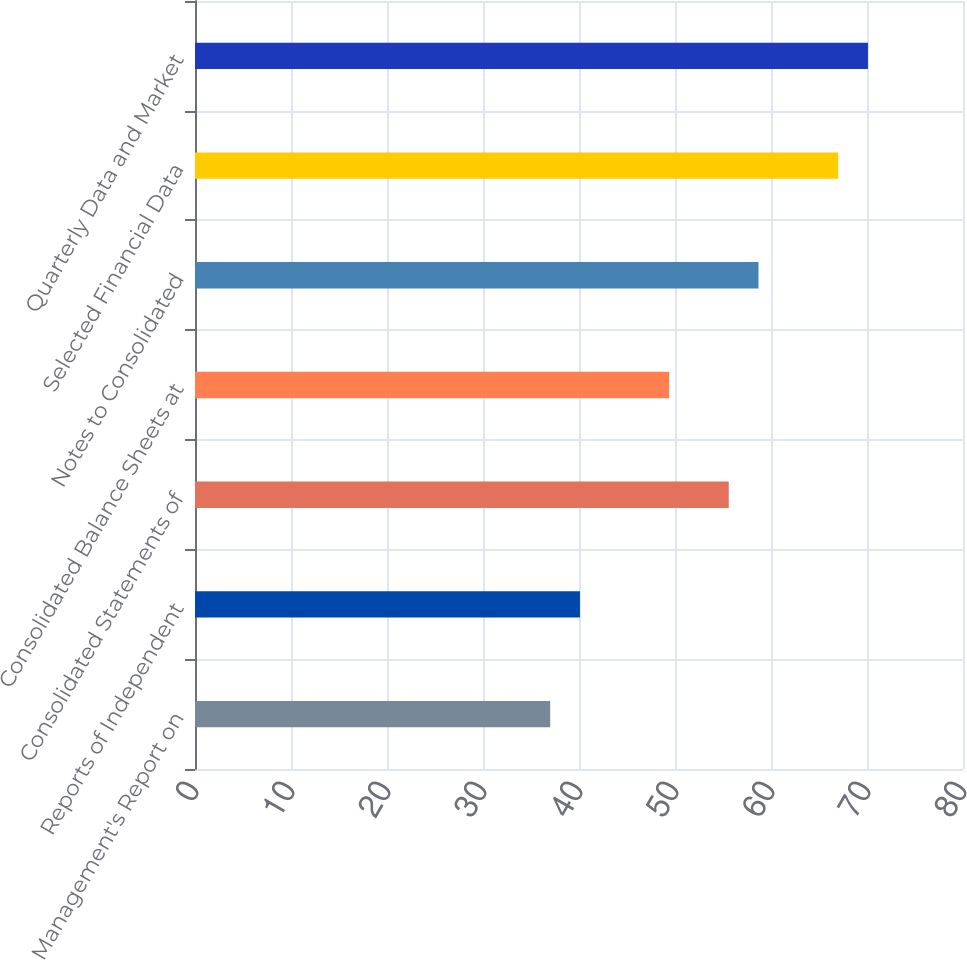<chart> <loc_0><loc_0><loc_500><loc_500><bar_chart><fcel>Management's Report on<fcel>Reports of Independent<fcel>Consolidated Statements of<fcel>Consolidated Balance Sheets at<fcel>Notes to Consolidated<fcel>Selected Financial Data<fcel>Quarterly Data and Market<nl><fcel>37<fcel>40.1<fcel>55.6<fcel>49.4<fcel>58.7<fcel>67<fcel>70.1<nl></chart> 